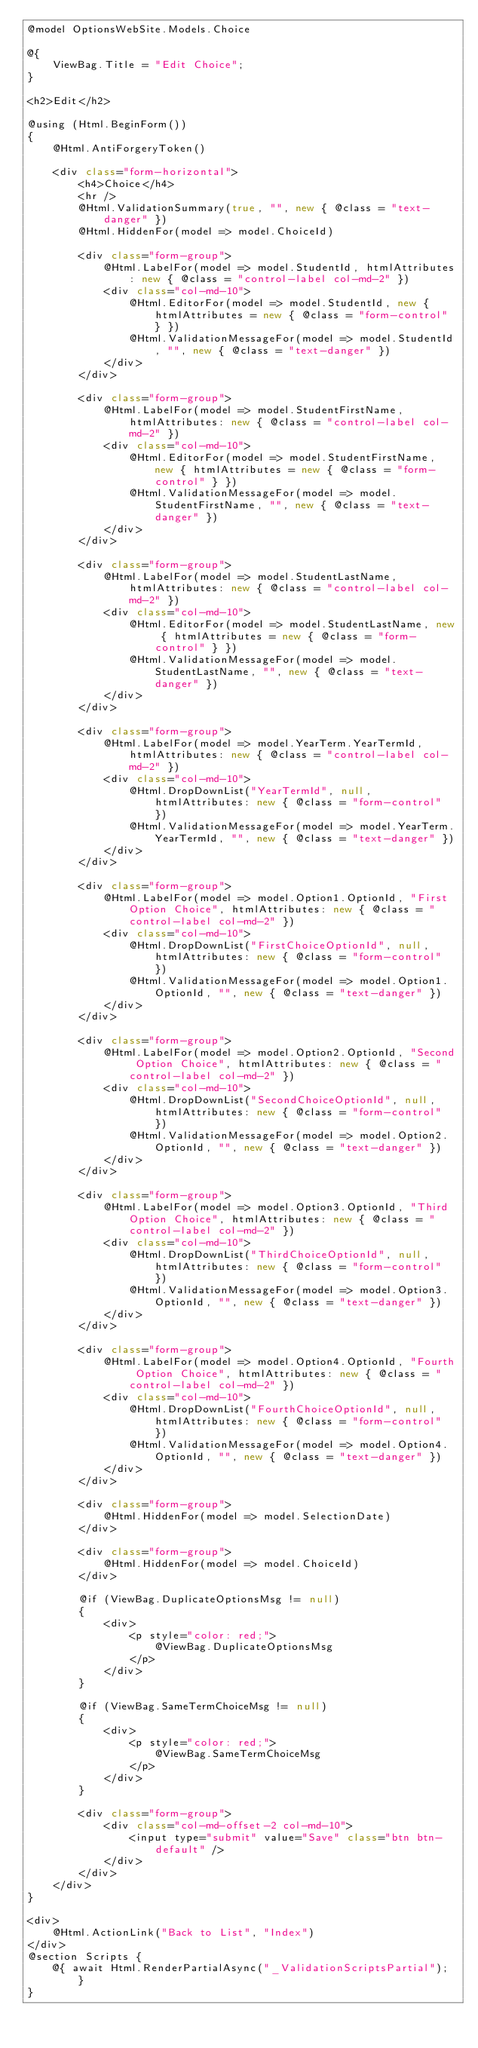Convert code to text. <code><loc_0><loc_0><loc_500><loc_500><_C#_>@model OptionsWebSite.Models.Choice

@{
    ViewBag.Title = "Edit Choice";
}

<h2>Edit</h2>

@using (Html.BeginForm())
{
    @Html.AntiForgeryToken()
    
    <div class="form-horizontal">
        <h4>Choice</h4>
        <hr />
        @Html.ValidationSummary(true, "", new { @class = "text-danger" })
        @Html.HiddenFor(model => model.ChoiceId)

        <div class="form-group">
            @Html.LabelFor(model => model.StudentId, htmlAttributes: new { @class = "control-label col-md-2" })
            <div class="col-md-10">
                @Html.EditorFor(model => model.StudentId, new { htmlAttributes = new { @class = "form-control" } })
                @Html.ValidationMessageFor(model => model.StudentId, "", new { @class = "text-danger" })
            </div>
        </div>

        <div class="form-group">
            @Html.LabelFor(model => model.StudentFirstName, htmlAttributes: new { @class = "control-label col-md-2" })
            <div class="col-md-10">
                @Html.EditorFor(model => model.StudentFirstName, new { htmlAttributes = new { @class = "form-control" } })
                @Html.ValidationMessageFor(model => model.StudentFirstName, "", new { @class = "text-danger" })
            </div>
        </div>

        <div class="form-group">
            @Html.LabelFor(model => model.StudentLastName, htmlAttributes: new { @class = "control-label col-md-2" })
            <div class="col-md-10">
                @Html.EditorFor(model => model.StudentLastName, new { htmlAttributes = new { @class = "form-control" } })
                @Html.ValidationMessageFor(model => model.StudentLastName, "", new { @class = "text-danger" })
            </div>
        </div>

        <div class="form-group">
            @Html.LabelFor(model => model.YearTerm.YearTermId, htmlAttributes: new { @class = "control-label col-md-2" })
            <div class="col-md-10">
                @Html.DropDownList("YearTermId", null, htmlAttributes: new { @class = "form-control" })
                @Html.ValidationMessageFor(model => model.YearTerm.YearTermId, "", new { @class = "text-danger" })
            </div>
        </div>

        <div class="form-group">
            @Html.LabelFor(model => model.Option1.OptionId, "First Option Choice", htmlAttributes: new { @class = "control-label col-md-2" })
            <div class="col-md-10">
                @Html.DropDownList("FirstChoiceOptionId", null, htmlAttributes: new { @class = "form-control" })
                @Html.ValidationMessageFor(model => model.Option1.OptionId, "", new { @class = "text-danger" })
            </div>
        </div>

        <div class="form-group">
            @Html.LabelFor(model => model.Option2.OptionId, "Second Option Choice", htmlAttributes: new { @class = "control-label col-md-2" })
            <div class="col-md-10">
                @Html.DropDownList("SecondChoiceOptionId", null, htmlAttributes: new { @class = "form-control" })
                @Html.ValidationMessageFor(model => model.Option2.OptionId, "", new { @class = "text-danger" })
            </div>
        </div>

        <div class="form-group">
            @Html.LabelFor(model => model.Option3.OptionId, "Third Option Choice", htmlAttributes: new { @class = "control-label col-md-2" })
            <div class="col-md-10">
                @Html.DropDownList("ThirdChoiceOptionId", null, htmlAttributes: new { @class = "form-control" })
                @Html.ValidationMessageFor(model => model.Option3.OptionId, "", new { @class = "text-danger" })
            </div>
        </div>

        <div class="form-group">
            @Html.LabelFor(model => model.Option4.OptionId, "Fourth Option Choice", htmlAttributes: new { @class = "control-label col-md-2" })
            <div class="col-md-10">
                @Html.DropDownList("FourthChoiceOptionId", null, htmlAttributes: new { @class = "form-control" })
                @Html.ValidationMessageFor(model => model.Option4.OptionId, "", new { @class = "text-danger" })
            </div>
        </div>

        <div class="form-group">
            @Html.HiddenFor(model => model.SelectionDate)
        </div>
        
        <div class="form-group">
            @Html.HiddenFor(model => model.ChoiceId)
        </div>

        @if (ViewBag.DuplicateOptionsMsg != null)
        {
            <div>
                <p style="color: red;">
                    @ViewBag.DuplicateOptionsMsg
                </p>
            </div>
        }

        @if (ViewBag.SameTermChoiceMsg != null)
        {
            <div>
                <p style="color: red;">
                    @ViewBag.SameTermChoiceMsg
                </p>
            </div>
        }

        <div class="form-group">
            <div class="col-md-offset-2 col-md-10">
                <input type="submit" value="Save" class="btn btn-default" />
            </div>
        </div>
    </div>
}

<div>
    @Html.ActionLink("Back to List", "Index")
</div>
@section Scripts {
    @{ await Html.RenderPartialAsync("_ValidationScriptsPartial"); }
}</code> 